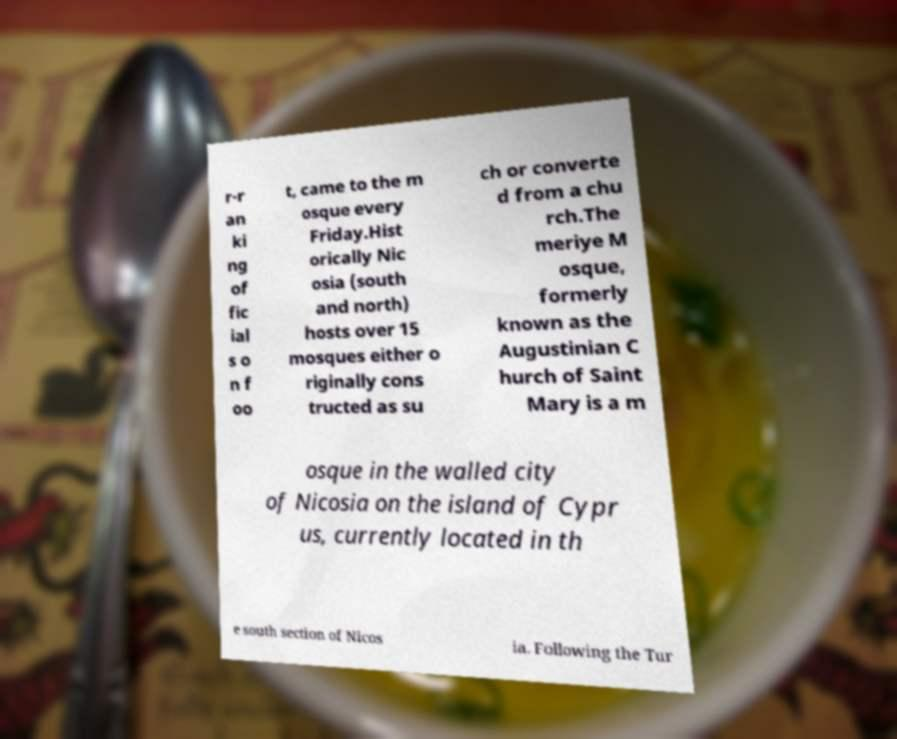Can you read and provide the text displayed in the image?This photo seems to have some interesting text. Can you extract and type it out for me? r-r an ki ng of fic ial s o n f oo t, came to the m osque every Friday.Hist orically Nic osia (south and north) hosts over 15 mosques either o riginally cons tructed as su ch or converte d from a chu rch.The meriye M osque, formerly known as the Augustinian C hurch of Saint Mary is a m osque in the walled city of Nicosia on the island of Cypr us, currently located in th e south section of Nicos ia. Following the Tur 